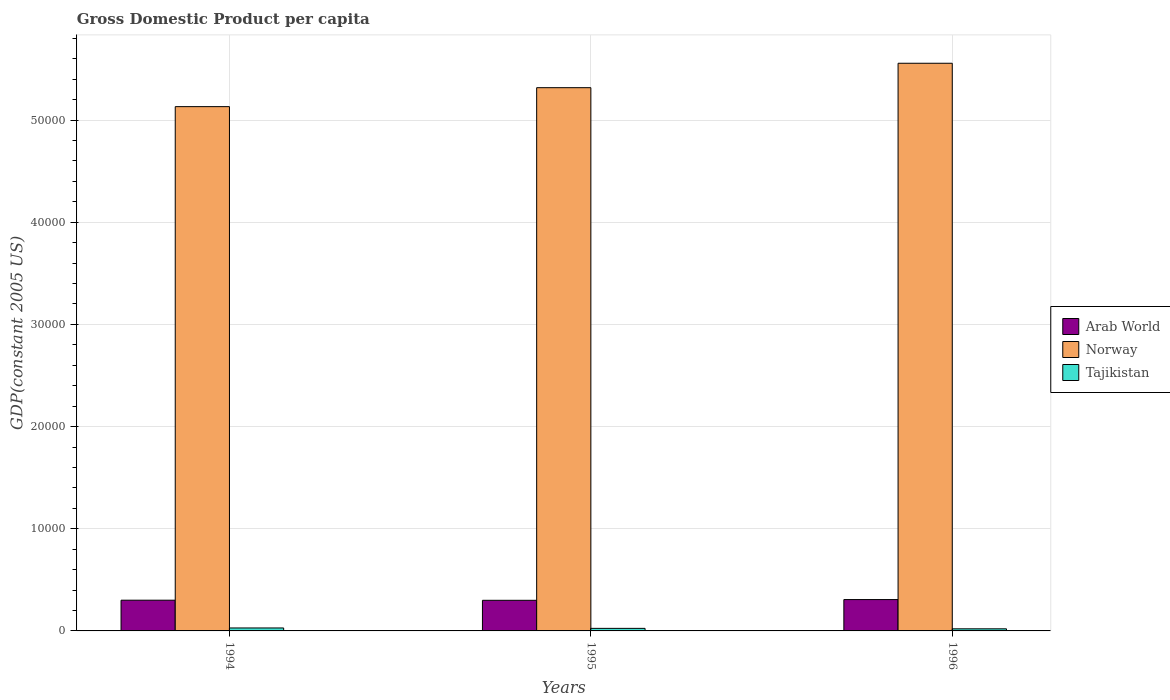How many different coloured bars are there?
Your response must be concise. 3. Are the number of bars per tick equal to the number of legend labels?
Offer a terse response. Yes. How many bars are there on the 2nd tick from the left?
Make the answer very short. 3. In how many cases, is the number of bars for a given year not equal to the number of legend labels?
Offer a very short reply. 0. What is the GDP per capita in Norway in 1995?
Provide a short and direct response. 5.32e+04. Across all years, what is the maximum GDP per capita in Norway?
Your response must be concise. 5.56e+04. Across all years, what is the minimum GDP per capita in Norway?
Provide a short and direct response. 5.13e+04. What is the total GDP per capita in Tajikistan in the graph?
Ensure brevity in your answer.  745.43. What is the difference between the GDP per capita in Norway in 1995 and that in 1996?
Your answer should be very brief. -2390.84. What is the difference between the GDP per capita in Norway in 1996 and the GDP per capita in Arab World in 1995?
Provide a succinct answer. 5.26e+04. What is the average GDP per capita in Norway per year?
Your answer should be compact. 5.33e+04. In the year 1994, what is the difference between the GDP per capita in Arab World and GDP per capita in Norway?
Provide a short and direct response. -4.83e+04. In how many years, is the GDP per capita in Arab World greater than 40000 US$?
Provide a succinct answer. 0. What is the ratio of the GDP per capita in Arab World in 1995 to that in 1996?
Give a very brief answer. 0.98. Is the difference between the GDP per capita in Arab World in 1994 and 1995 greater than the difference between the GDP per capita in Norway in 1994 and 1995?
Make the answer very short. Yes. What is the difference between the highest and the second highest GDP per capita in Tajikistan?
Your response must be concise. 39.5. What is the difference between the highest and the lowest GDP per capita in Tajikistan?
Your answer should be compact. 84.05. Is the sum of the GDP per capita in Norway in 1995 and 1996 greater than the maximum GDP per capita in Arab World across all years?
Your response must be concise. Yes. What does the 3rd bar from the left in 1994 represents?
Your answer should be compact. Tajikistan. What does the 1st bar from the right in 1995 represents?
Make the answer very short. Tajikistan. Is it the case that in every year, the sum of the GDP per capita in Tajikistan and GDP per capita in Arab World is greater than the GDP per capita in Norway?
Provide a short and direct response. No. How many bars are there?
Make the answer very short. 9. Are all the bars in the graph horizontal?
Your response must be concise. No. How many years are there in the graph?
Provide a succinct answer. 3. Are the values on the major ticks of Y-axis written in scientific E-notation?
Your response must be concise. No. Does the graph contain any zero values?
Offer a terse response. No. Does the graph contain grids?
Offer a very short reply. Yes. How many legend labels are there?
Offer a terse response. 3. How are the legend labels stacked?
Provide a succinct answer. Vertical. What is the title of the graph?
Your answer should be very brief. Gross Domestic Product per capita. What is the label or title of the Y-axis?
Offer a terse response. GDP(constant 2005 US). What is the GDP(constant 2005 US) of Arab World in 1994?
Your response must be concise. 3007.39. What is the GDP(constant 2005 US) in Norway in 1994?
Your answer should be very brief. 5.13e+04. What is the GDP(constant 2005 US) of Tajikistan in 1994?
Offer a terse response. 289.66. What is the GDP(constant 2005 US) in Arab World in 1995?
Offer a very short reply. 2995.86. What is the GDP(constant 2005 US) of Norway in 1995?
Offer a terse response. 5.32e+04. What is the GDP(constant 2005 US) of Tajikistan in 1995?
Your answer should be compact. 250.16. What is the GDP(constant 2005 US) of Arab World in 1996?
Offer a very short reply. 3068.57. What is the GDP(constant 2005 US) of Norway in 1996?
Your answer should be compact. 5.56e+04. What is the GDP(constant 2005 US) in Tajikistan in 1996?
Offer a very short reply. 205.61. Across all years, what is the maximum GDP(constant 2005 US) in Arab World?
Ensure brevity in your answer.  3068.57. Across all years, what is the maximum GDP(constant 2005 US) in Norway?
Provide a short and direct response. 5.56e+04. Across all years, what is the maximum GDP(constant 2005 US) in Tajikistan?
Offer a very short reply. 289.66. Across all years, what is the minimum GDP(constant 2005 US) in Arab World?
Your response must be concise. 2995.86. Across all years, what is the minimum GDP(constant 2005 US) of Norway?
Offer a very short reply. 5.13e+04. Across all years, what is the minimum GDP(constant 2005 US) of Tajikistan?
Offer a very short reply. 205.61. What is the total GDP(constant 2005 US) in Arab World in the graph?
Offer a terse response. 9071.82. What is the total GDP(constant 2005 US) of Norway in the graph?
Your answer should be compact. 1.60e+05. What is the total GDP(constant 2005 US) in Tajikistan in the graph?
Offer a very short reply. 745.43. What is the difference between the GDP(constant 2005 US) in Arab World in 1994 and that in 1995?
Give a very brief answer. 11.53. What is the difference between the GDP(constant 2005 US) of Norway in 1994 and that in 1995?
Give a very brief answer. -1854.71. What is the difference between the GDP(constant 2005 US) in Tajikistan in 1994 and that in 1995?
Offer a very short reply. 39.5. What is the difference between the GDP(constant 2005 US) in Arab World in 1994 and that in 1996?
Your response must be concise. -61.17. What is the difference between the GDP(constant 2005 US) in Norway in 1994 and that in 1996?
Your response must be concise. -4245.54. What is the difference between the GDP(constant 2005 US) in Tajikistan in 1994 and that in 1996?
Offer a very short reply. 84.05. What is the difference between the GDP(constant 2005 US) in Arab World in 1995 and that in 1996?
Provide a succinct answer. -72.7. What is the difference between the GDP(constant 2005 US) of Norway in 1995 and that in 1996?
Your answer should be very brief. -2390.84. What is the difference between the GDP(constant 2005 US) in Tajikistan in 1995 and that in 1996?
Provide a succinct answer. 44.55. What is the difference between the GDP(constant 2005 US) of Arab World in 1994 and the GDP(constant 2005 US) of Norway in 1995?
Keep it short and to the point. -5.02e+04. What is the difference between the GDP(constant 2005 US) of Arab World in 1994 and the GDP(constant 2005 US) of Tajikistan in 1995?
Make the answer very short. 2757.24. What is the difference between the GDP(constant 2005 US) in Norway in 1994 and the GDP(constant 2005 US) in Tajikistan in 1995?
Offer a very short reply. 5.11e+04. What is the difference between the GDP(constant 2005 US) in Arab World in 1994 and the GDP(constant 2005 US) in Norway in 1996?
Your answer should be very brief. -5.25e+04. What is the difference between the GDP(constant 2005 US) in Arab World in 1994 and the GDP(constant 2005 US) in Tajikistan in 1996?
Your answer should be compact. 2801.78. What is the difference between the GDP(constant 2005 US) in Norway in 1994 and the GDP(constant 2005 US) in Tajikistan in 1996?
Provide a succinct answer. 5.11e+04. What is the difference between the GDP(constant 2005 US) of Arab World in 1995 and the GDP(constant 2005 US) of Norway in 1996?
Give a very brief answer. -5.26e+04. What is the difference between the GDP(constant 2005 US) in Arab World in 1995 and the GDP(constant 2005 US) in Tajikistan in 1996?
Your answer should be very brief. 2790.25. What is the difference between the GDP(constant 2005 US) of Norway in 1995 and the GDP(constant 2005 US) of Tajikistan in 1996?
Your answer should be very brief. 5.30e+04. What is the average GDP(constant 2005 US) in Arab World per year?
Offer a very short reply. 3023.94. What is the average GDP(constant 2005 US) in Norway per year?
Provide a short and direct response. 5.33e+04. What is the average GDP(constant 2005 US) of Tajikistan per year?
Offer a terse response. 248.48. In the year 1994, what is the difference between the GDP(constant 2005 US) of Arab World and GDP(constant 2005 US) of Norway?
Offer a very short reply. -4.83e+04. In the year 1994, what is the difference between the GDP(constant 2005 US) in Arab World and GDP(constant 2005 US) in Tajikistan?
Keep it short and to the point. 2717.73. In the year 1994, what is the difference between the GDP(constant 2005 US) of Norway and GDP(constant 2005 US) of Tajikistan?
Provide a short and direct response. 5.10e+04. In the year 1995, what is the difference between the GDP(constant 2005 US) of Arab World and GDP(constant 2005 US) of Norway?
Provide a short and direct response. -5.02e+04. In the year 1995, what is the difference between the GDP(constant 2005 US) in Arab World and GDP(constant 2005 US) in Tajikistan?
Make the answer very short. 2745.7. In the year 1995, what is the difference between the GDP(constant 2005 US) in Norway and GDP(constant 2005 US) in Tajikistan?
Your answer should be very brief. 5.29e+04. In the year 1996, what is the difference between the GDP(constant 2005 US) in Arab World and GDP(constant 2005 US) in Norway?
Make the answer very short. -5.25e+04. In the year 1996, what is the difference between the GDP(constant 2005 US) in Arab World and GDP(constant 2005 US) in Tajikistan?
Provide a succinct answer. 2862.95. In the year 1996, what is the difference between the GDP(constant 2005 US) in Norway and GDP(constant 2005 US) in Tajikistan?
Provide a succinct answer. 5.54e+04. What is the ratio of the GDP(constant 2005 US) in Arab World in 1994 to that in 1995?
Keep it short and to the point. 1. What is the ratio of the GDP(constant 2005 US) of Norway in 1994 to that in 1995?
Make the answer very short. 0.97. What is the ratio of the GDP(constant 2005 US) in Tajikistan in 1994 to that in 1995?
Ensure brevity in your answer.  1.16. What is the ratio of the GDP(constant 2005 US) of Arab World in 1994 to that in 1996?
Keep it short and to the point. 0.98. What is the ratio of the GDP(constant 2005 US) in Norway in 1994 to that in 1996?
Offer a terse response. 0.92. What is the ratio of the GDP(constant 2005 US) in Tajikistan in 1994 to that in 1996?
Provide a short and direct response. 1.41. What is the ratio of the GDP(constant 2005 US) in Arab World in 1995 to that in 1996?
Keep it short and to the point. 0.98. What is the ratio of the GDP(constant 2005 US) in Norway in 1995 to that in 1996?
Keep it short and to the point. 0.96. What is the ratio of the GDP(constant 2005 US) in Tajikistan in 1995 to that in 1996?
Give a very brief answer. 1.22. What is the difference between the highest and the second highest GDP(constant 2005 US) of Arab World?
Offer a very short reply. 61.17. What is the difference between the highest and the second highest GDP(constant 2005 US) in Norway?
Make the answer very short. 2390.84. What is the difference between the highest and the second highest GDP(constant 2005 US) of Tajikistan?
Provide a short and direct response. 39.5. What is the difference between the highest and the lowest GDP(constant 2005 US) of Arab World?
Your answer should be very brief. 72.7. What is the difference between the highest and the lowest GDP(constant 2005 US) of Norway?
Provide a succinct answer. 4245.54. What is the difference between the highest and the lowest GDP(constant 2005 US) in Tajikistan?
Ensure brevity in your answer.  84.05. 